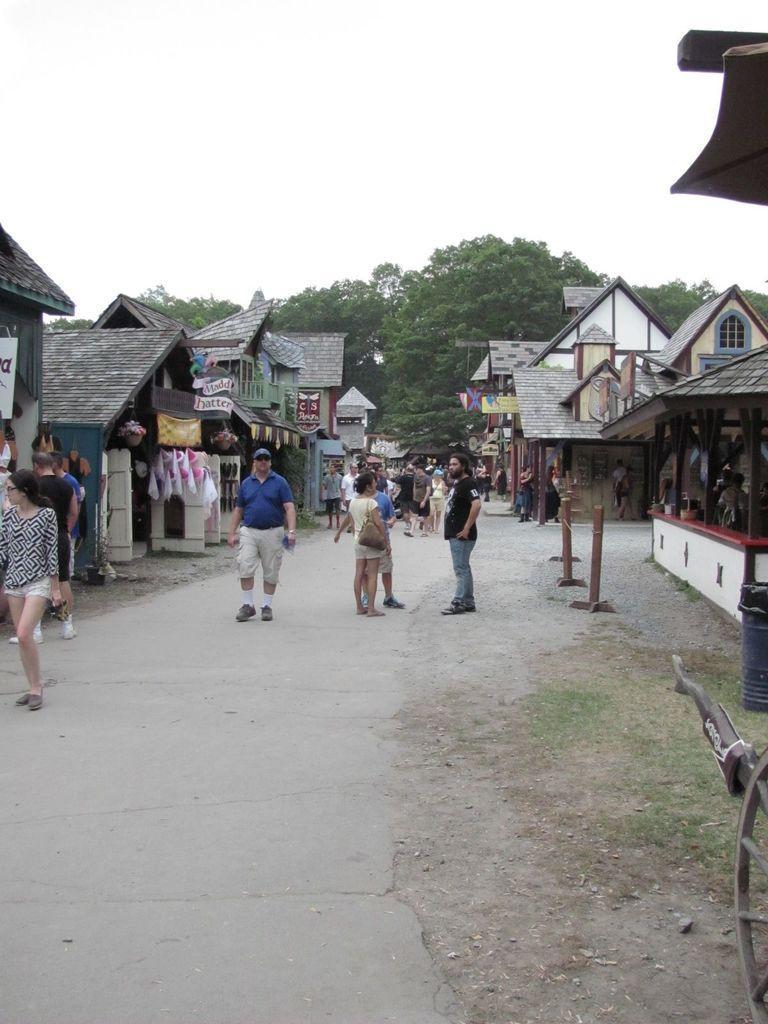Could you give a brief overview of what you see in this image? There is a road. On the road there are many people. On the sides of the road there are buildings. Also there are many items. In the background there are trees and sky. 